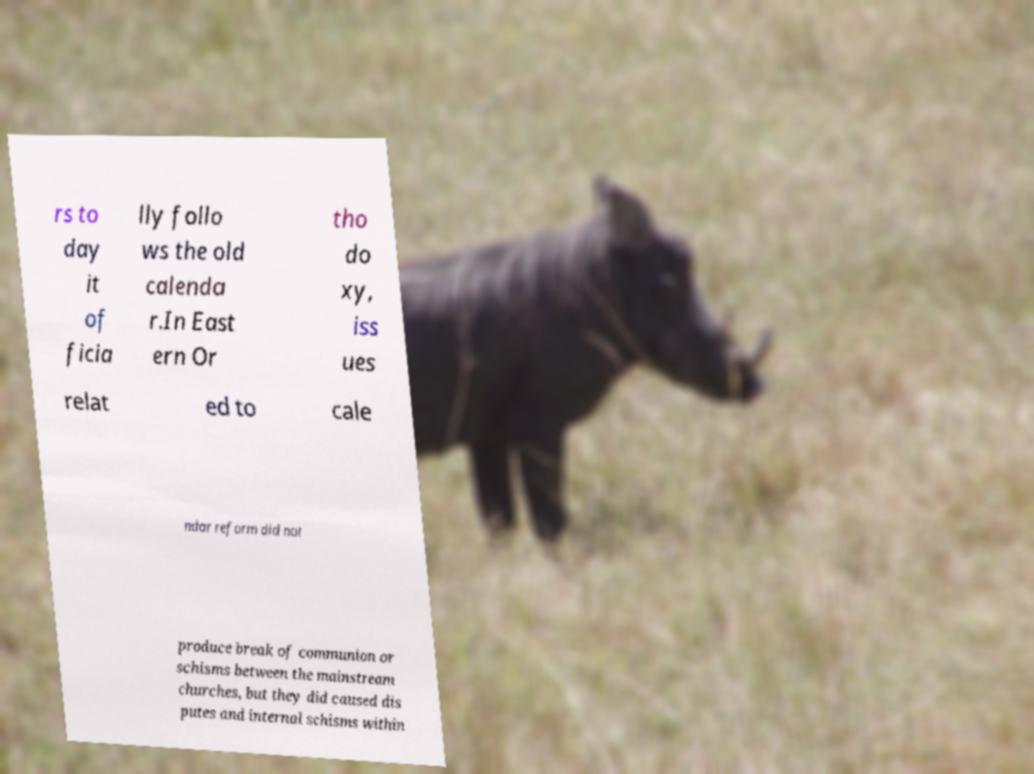Can you accurately transcribe the text from the provided image for me? rs to day it of ficia lly follo ws the old calenda r.In East ern Or tho do xy, iss ues relat ed to cale ndar reform did not produce break of communion or schisms between the mainstream churches, but they did caused dis putes and internal schisms within 